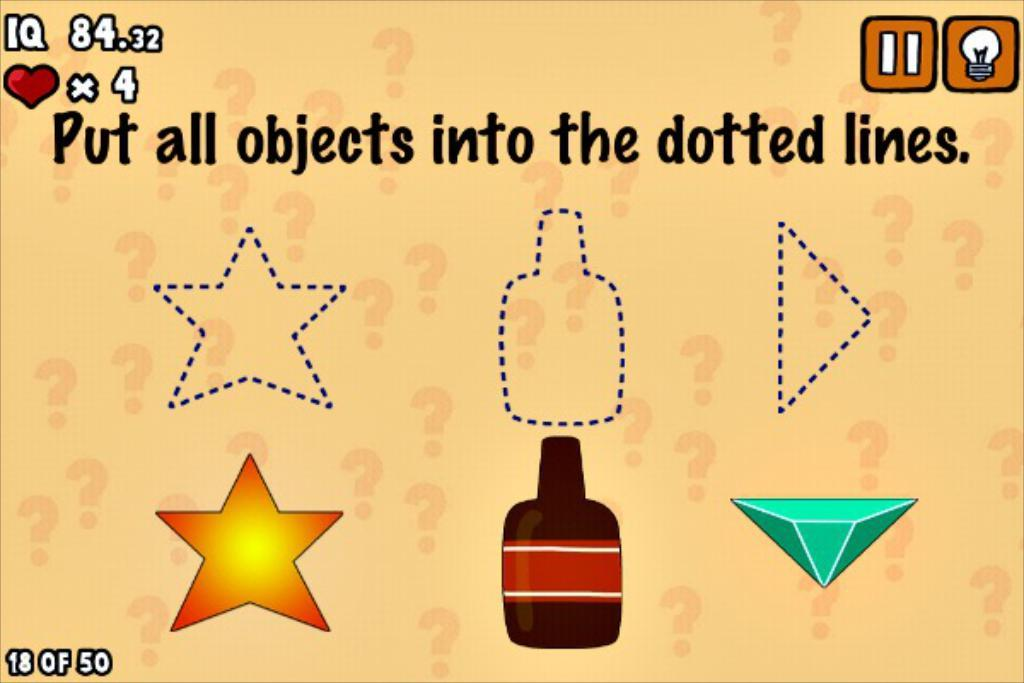<image>
Relay a brief, clear account of the picture shown. a page that says 'put all objects into the dotted lines.' on it 